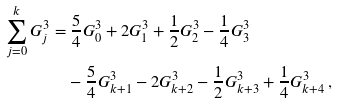<formula> <loc_0><loc_0><loc_500><loc_500>\sum _ { j = 0 } ^ { k } { G _ { j } ^ { 3 } } & = \frac { 5 } { 4 } G _ { 0 } ^ { 3 } + 2 G _ { 1 } ^ { 3 } + \frac { 1 } { 2 } G _ { 2 } ^ { 3 } - \frac { 1 } { 4 } G _ { 3 } ^ { 3 } \\ & \quad - \frac { 5 } { 4 } G _ { k + 1 } ^ { 3 } - 2 G _ { k + 2 } ^ { 3 } - \frac { 1 } { 2 } G _ { k + 3 } ^ { 3 } + \frac { 1 } { 4 } G _ { k + 4 } ^ { 3 } \, ,</formula> 